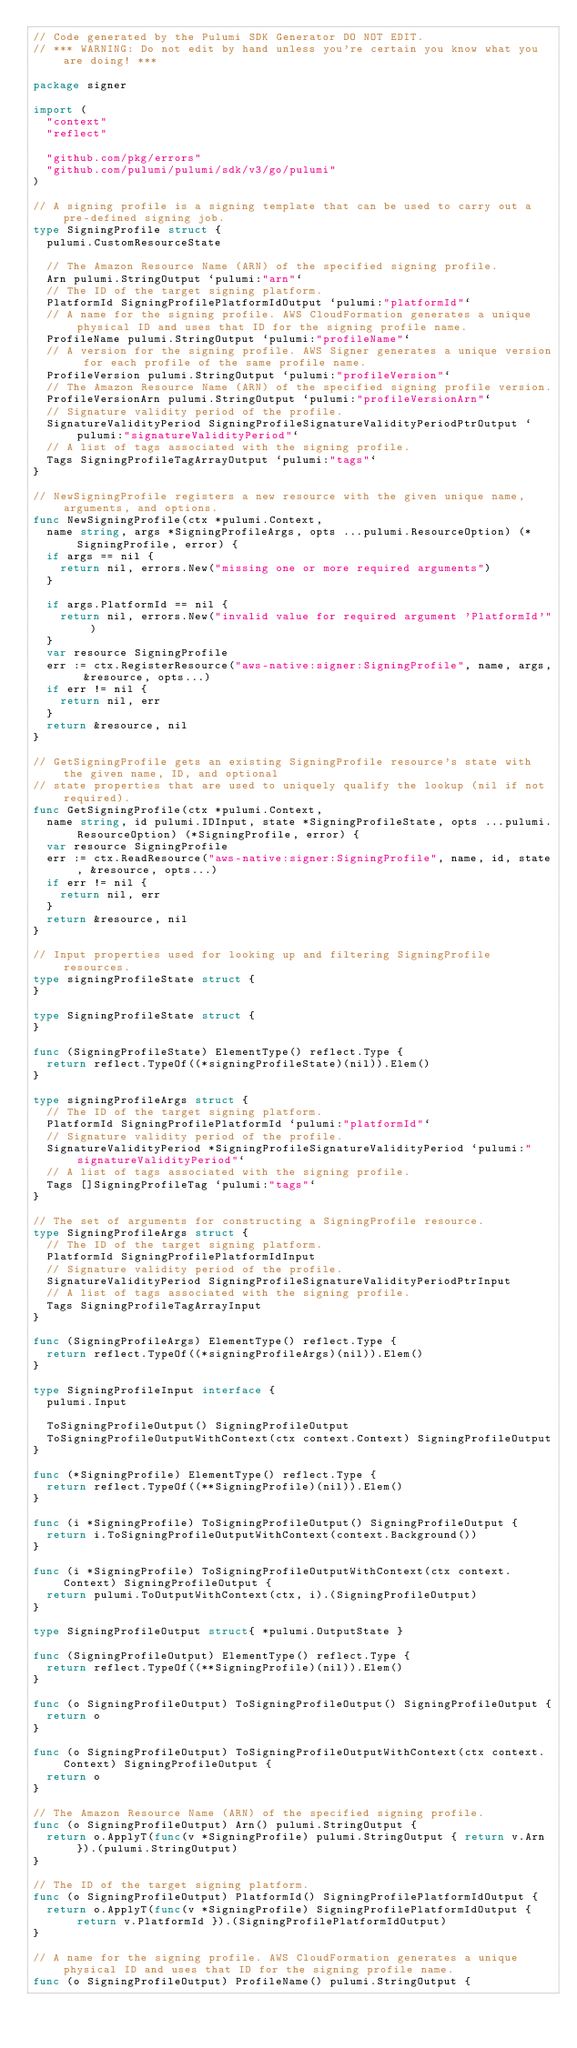<code> <loc_0><loc_0><loc_500><loc_500><_Go_>// Code generated by the Pulumi SDK Generator DO NOT EDIT.
// *** WARNING: Do not edit by hand unless you're certain you know what you are doing! ***

package signer

import (
	"context"
	"reflect"

	"github.com/pkg/errors"
	"github.com/pulumi/pulumi/sdk/v3/go/pulumi"
)

// A signing profile is a signing template that can be used to carry out a pre-defined signing job.
type SigningProfile struct {
	pulumi.CustomResourceState

	// The Amazon Resource Name (ARN) of the specified signing profile.
	Arn pulumi.StringOutput `pulumi:"arn"`
	// The ID of the target signing platform.
	PlatformId SigningProfilePlatformIdOutput `pulumi:"platformId"`
	// A name for the signing profile. AWS CloudFormation generates a unique physical ID and uses that ID for the signing profile name.
	ProfileName pulumi.StringOutput `pulumi:"profileName"`
	// A version for the signing profile. AWS Signer generates a unique version for each profile of the same profile name.
	ProfileVersion pulumi.StringOutput `pulumi:"profileVersion"`
	// The Amazon Resource Name (ARN) of the specified signing profile version.
	ProfileVersionArn pulumi.StringOutput `pulumi:"profileVersionArn"`
	// Signature validity period of the profile.
	SignatureValidityPeriod SigningProfileSignatureValidityPeriodPtrOutput `pulumi:"signatureValidityPeriod"`
	// A list of tags associated with the signing profile.
	Tags SigningProfileTagArrayOutput `pulumi:"tags"`
}

// NewSigningProfile registers a new resource with the given unique name, arguments, and options.
func NewSigningProfile(ctx *pulumi.Context,
	name string, args *SigningProfileArgs, opts ...pulumi.ResourceOption) (*SigningProfile, error) {
	if args == nil {
		return nil, errors.New("missing one or more required arguments")
	}

	if args.PlatformId == nil {
		return nil, errors.New("invalid value for required argument 'PlatformId'")
	}
	var resource SigningProfile
	err := ctx.RegisterResource("aws-native:signer:SigningProfile", name, args, &resource, opts...)
	if err != nil {
		return nil, err
	}
	return &resource, nil
}

// GetSigningProfile gets an existing SigningProfile resource's state with the given name, ID, and optional
// state properties that are used to uniquely qualify the lookup (nil if not required).
func GetSigningProfile(ctx *pulumi.Context,
	name string, id pulumi.IDInput, state *SigningProfileState, opts ...pulumi.ResourceOption) (*SigningProfile, error) {
	var resource SigningProfile
	err := ctx.ReadResource("aws-native:signer:SigningProfile", name, id, state, &resource, opts...)
	if err != nil {
		return nil, err
	}
	return &resource, nil
}

// Input properties used for looking up and filtering SigningProfile resources.
type signingProfileState struct {
}

type SigningProfileState struct {
}

func (SigningProfileState) ElementType() reflect.Type {
	return reflect.TypeOf((*signingProfileState)(nil)).Elem()
}

type signingProfileArgs struct {
	// The ID of the target signing platform.
	PlatformId SigningProfilePlatformId `pulumi:"platformId"`
	// Signature validity period of the profile.
	SignatureValidityPeriod *SigningProfileSignatureValidityPeriod `pulumi:"signatureValidityPeriod"`
	// A list of tags associated with the signing profile.
	Tags []SigningProfileTag `pulumi:"tags"`
}

// The set of arguments for constructing a SigningProfile resource.
type SigningProfileArgs struct {
	// The ID of the target signing platform.
	PlatformId SigningProfilePlatformIdInput
	// Signature validity period of the profile.
	SignatureValidityPeriod SigningProfileSignatureValidityPeriodPtrInput
	// A list of tags associated with the signing profile.
	Tags SigningProfileTagArrayInput
}

func (SigningProfileArgs) ElementType() reflect.Type {
	return reflect.TypeOf((*signingProfileArgs)(nil)).Elem()
}

type SigningProfileInput interface {
	pulumi.Input

	ToSigningProfileOutput() SigningProfileOutput
	ToSigningProfileOutputWithContext(ctx context.Context) SigningProfileOutput
}

func (*SigningProfile) ElementType() reflect.Type {
	return reflect.TypeOf((**SigningProfile)(nil)).Elem()
}

func (i *SigningProfile) ToSigningProfileOutput() SigningProfileOutput {
	return i.ToSigningProfileOutputWithContext(context.Background())
}

func (i *SigningProfile) ToSigningProfileOutputWithContext(ctx context.Context) SigningProfileOutput {
	return pulumi.ToOutputWithContext(ctx, i).(SigningProfileOutput)
}

type SigningProfileOutput struct{ *pulumi.OutputState }

func (SigningProfileOutput) ElementType() reflect.Type {
	return reflect.TypeOf((**SigningProfile)(nil)).Elem()
}

func (o SigningProfileOutput) ToSigningProfileOutput() SigningProfileOutput {
	return o
}

func (o SigningProfileOutput) ToSigningProfileOutputWithContext(ctx context.Context) SigningProfileOutput {
	return o
}

// The Amazon Resource Name (ARN) of the specified signing profile.
func (o SigningProfileOutput) Arn() pulumi.StringOutput {
	return o.ApplyT(func(v *SigningProfile) pulumi.StringOutput { return v.Arn }).(pulumi.StringOutput)
}

// The ID of the target signing platform.
func (o SigningProfileOutput) PlatformId() SigningProfilePlatformIdOutput {
	return o.ApplyT(func(v *SigningProfile) SigningProfilePlatformIdOutput { return v.PlatformId }).(SigningProfilePlatformIdOutput)
}

// A name for the signing profile. AWS CloudFormation generates a unique physical ID and uses that ID for the signing profile name.
func (o SigningProfileOutput) ProfileName() pulumi.StringOutput {</code> 